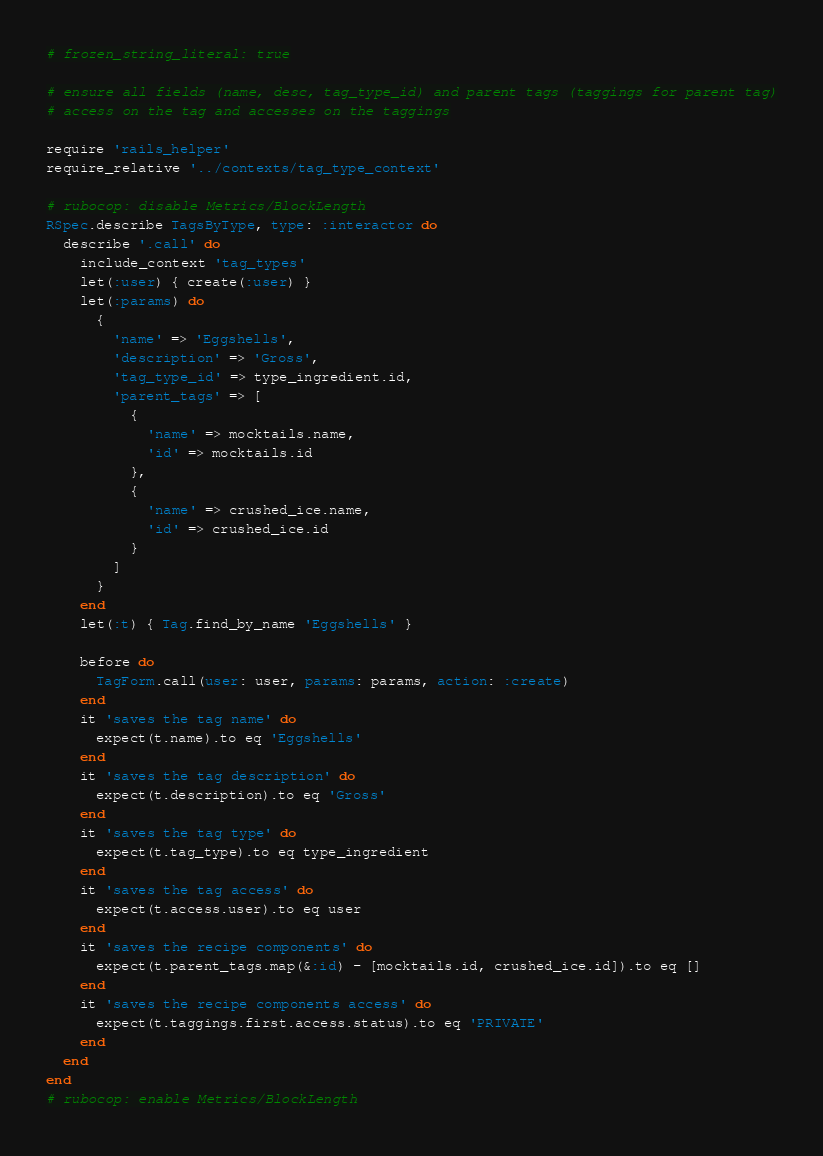<code> <loc_0><loc_0><loc_500><loc_500><_Ruby_># frozen_string_literal: true

# ensure all fields (name, desc, tag_type_id) and parent tags (taggings for parent tag)
# access on the tag and accesses on the taggings

require 'rails_helper'
require_relative '../contexts/tag_type_context'

# rubocop: disable Metrics/BlockLength
RSpec.describe TagsByType, type: :interactor do
  describe '.call' do
    include_context 'tag_types'
    let(:user) { create(:user) }
    let(:params) do
      {
        'name' => 'Eggshells',
        'description' => 'Gross',
        'tag_type_id' => type_ingredient.id,
        'parent_tags' => [
          {
            'name' => mocktails.name,
            'id' => mocktails.id
          },
          {
            'name' => crushed_ice.name,
            'id' => crushed_ice.id
          }
        ]
      }
    end
    let(:t) { Tag.find_by_name 'Eggshells' }

    before do
      TagForm.call(user: user, params: params, action: :create)
    end
    it 'saves the tag name' do
      expect(t.name).to eq 'Eggshells'
    end
    it 'saves the tag description' do
      expect(t.description).to eq 'Gross'
    end
    it 'saves the tag type' do
      expect(t.tag_type).to eq type_ingredient
    end
    it 'saves the tag access' do
      expect(t.access.user).to eq user
    end
    it 'saves the recipe components' do
      expect(t.parent_tags.map(&:id) - [mocktails.id, crushed_ice.id]).to eq []
    end
    it 'saves the recipe components access' do
      expect(t.taggings.first.access.status).to eq 'PRIVATE'
    end
  end
end
# rubocop: enable Metrics/BlockLength
</code> 